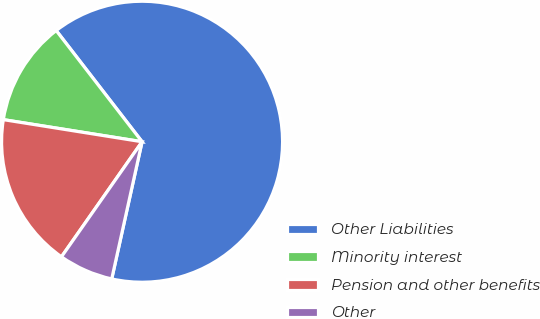Convert chart. <chart><loc_0><loc_0><loc_500><loc_500><pie_chart><fcel>Other Liabilities<fcel>Minority interest<fcel>Pension and other benefits<fcel>Other<nl><fcel>63.93%<fcel>12.02%<fcel>17.79%<fcel>6.26%<nl></chart> 